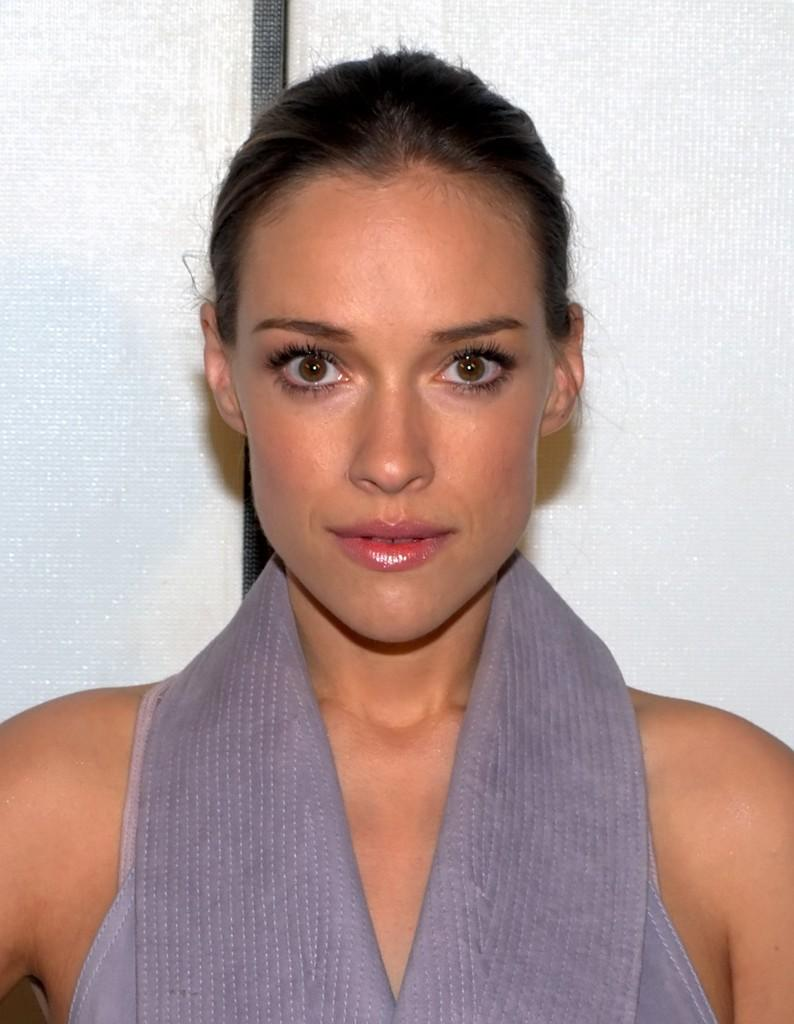Who is the main subject in the image? There is a lady in the image. What can be seen in the background of the image? There is a wall in the background of the image. How does the lady escape from the quicksand in the image? There is no quicksand present in the image; it only features a lady and a wall in the background. 